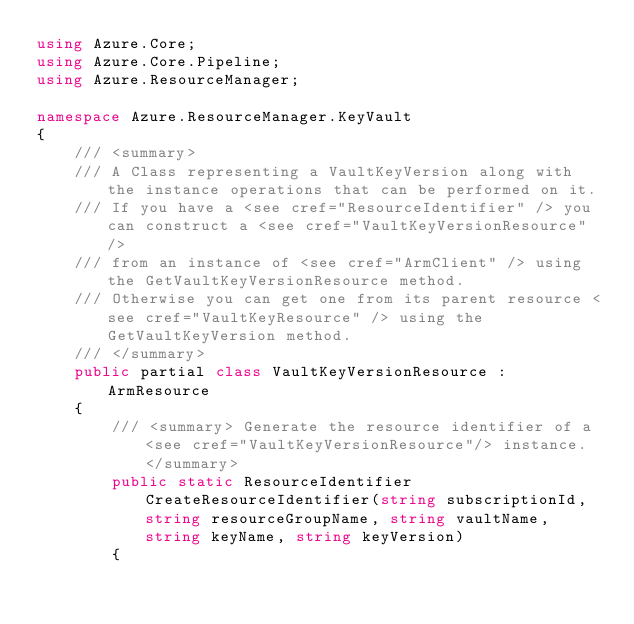Convert code to text. <code><loc_0><loc_0><loc_500><loc_500><_C#_>using Azure.Core;
using Azure.Core.Pipeline;
using Azure.ResourceManager;

namespace Azure.ResourceManager.KeyVault
{
    /// <summary>
    /// A Class representing a VaultKeyVersion along with the instance operations that can be performed on it.
    /// If you have a <see cref="ResourceIdentifier" /> you can construct a <see cref="VaultKeyVersionResource" />
    /// from an instance of <see cref="ArmClient" /> using the GetVaultKeyVersionResource method.
    /// Otherwise you can get one from its parent resource <see cref="VaultKeyResource" /> using the GetVaultKeyVersion method.
    /// </summary>
    public partial class VaultKeyVersionResource : ArmResource
    {
        /// <summary> Generate the resource identifier of a <see cref="VaultKeyVersionResource"/> instance. </summary>
        public static ResourceIdentifier CreateResourceIdentifier(string subscriptionId, string resourceGroupName, string vaultName, string keyName, string keyVersion)
        {</code> 